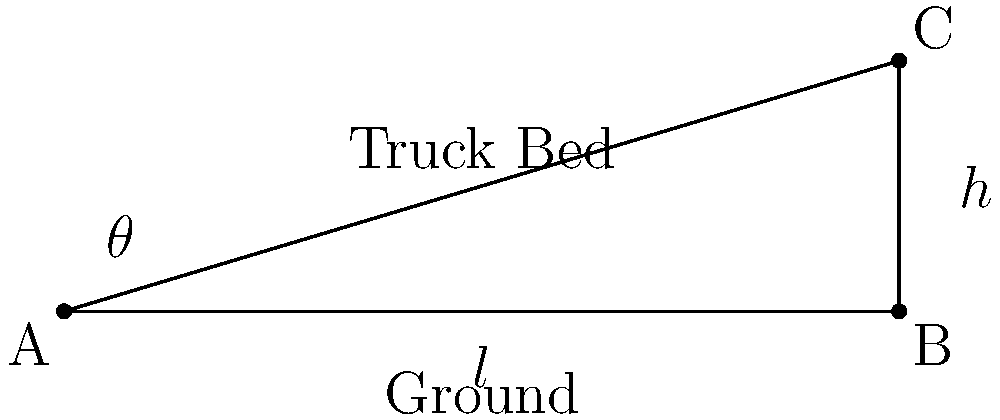You're designing a custom truck bed with adjustable rake angle for optimal load distribution. The truck bed is 100 inches long and can be raised to a maximum height of 30 inches at the rear. If you want to set the rake angle to 15°, what height (in inches) should you set the rear of the bed to? Round your answer to the nearest inch. To solve this problem, we'll use trigonometry. Let's break it down step by step:

1) In the diagram, we have a right triangle where:
   - The base (l) is the length of the truck bed: 100 inches
   - The angle ($\theta$) we want to achieve is 15°
   - We need to find the height (h)

2) We can use the tangent function to relate the angle to the opposite and adjacent sides:

   $\tan(\theta) = \frac{\text{opposite}}{\text{adjacent}} = \frac{h}{l}$

3) Rearranging this equation to solve for h:

   $h = l \times \tan(\theta)$

4) Now, let's plug in our known values:
   
   $h = 100 \times \tan(15°)$

5) Using a calculator or trigonometric tables:

   $h = 100 \times 0.2679$
   $h = 26.79$ inches

6) Rounding to the nearest inch:

   $h \approx 27$ inches

Therefore, to achieve a 15° rake angle on a 100-inch truck bed, you should set the rear height to 27 inches.
Answer: 27 inches 